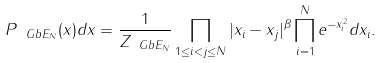<formula> <loc_0><loc_0><loc_500><loc_500>P _ { \ G b E _ { N } } ( x ) d x = \frac { 1 } { Z _ { \ G b E _ { N } } } \prod _ { 1 \leq i < j \leq N } | x _ { i } - x _ { j } | ^ { \beta } \prod _ { i = 1 } ^ { N } e ^ { - x _ { i } ^ { 2 } } d x _ { i } .</formula> 